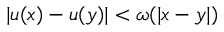<formula> <loc_0><loc_0><loc_500><loc_500>| u ( x ) - u ( y ) | < \omega ( | x - y | )</formula> 